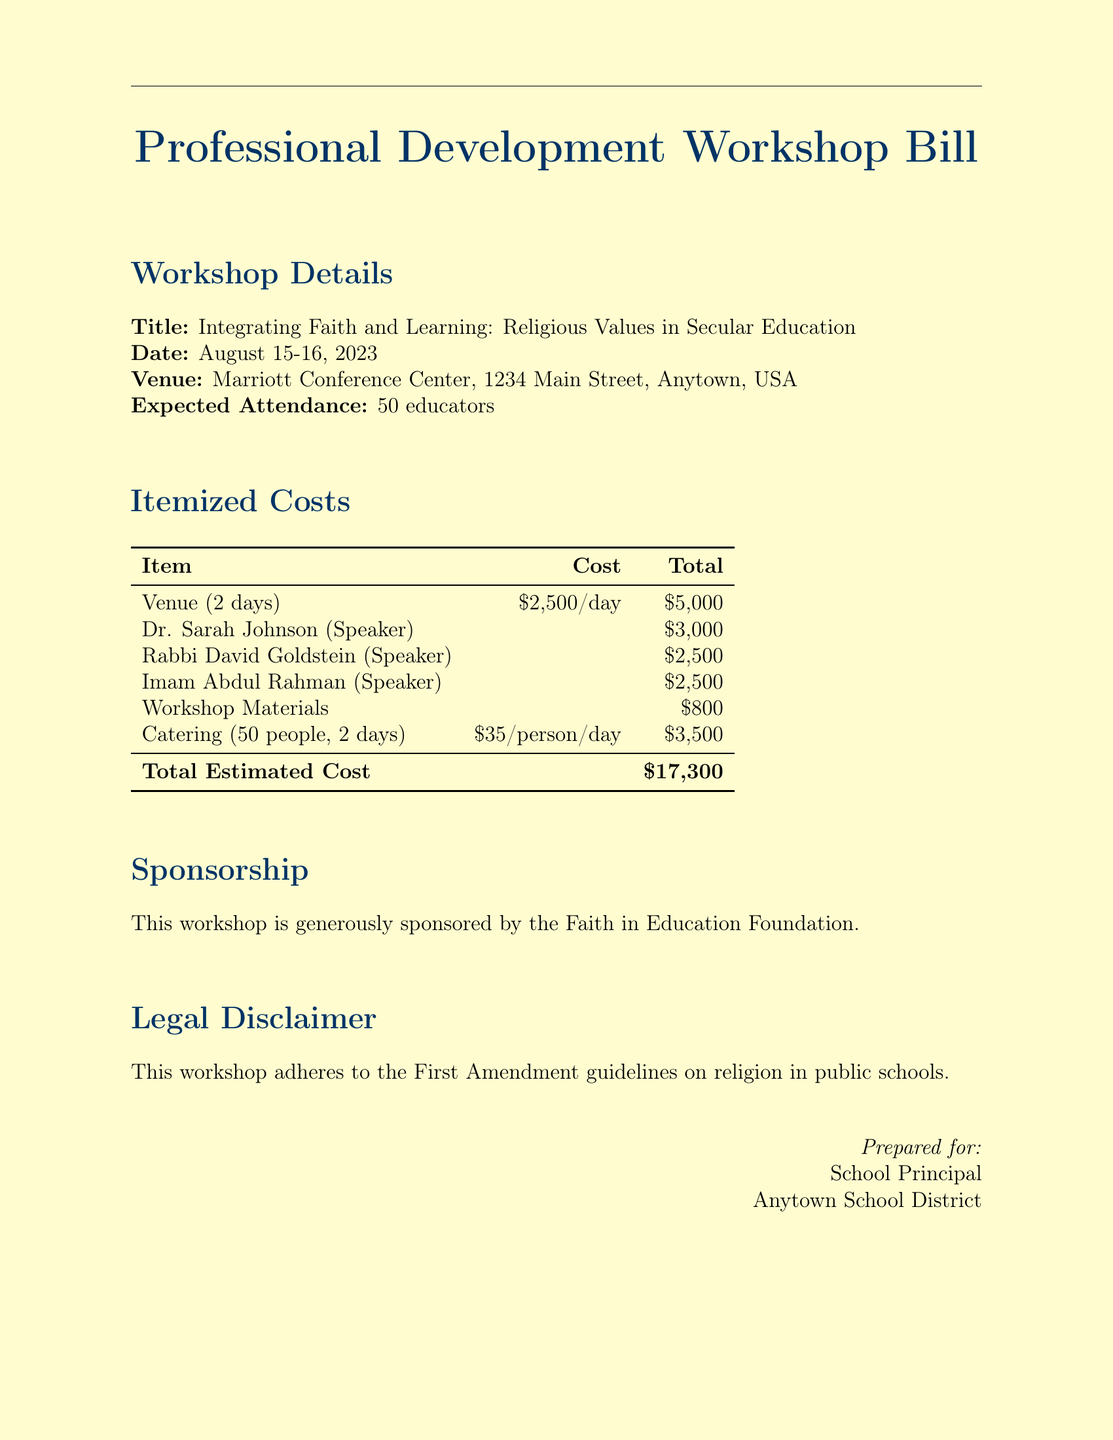What is the title of the workshop? The title of the workshop is explicitly mentioned in the document, providing clarity on the subject matter being discussed.
Answer: Integrating Faith and Learning: Religious Values in Secular Education What is the venue of the workshop? The venue is clearly specified in the document, allowing attendees to know where the workshop will take place.
Answer: Marriott Conference Center, 1234 Main Street, Anytown, USA How much does catering cost for 50 people over 2 days? The catering cost is itemized in the document, and the total can be determined from the per person cost.
Answer: $3,500 Who is the speaker with the highest fee? The speaker fees are listed, and comparing them leads to identifying the one with the highest charge.
Answer: Dr. Sarah Johnson What is the total estimated cost of the workshop? The total estimated cost is explicitly stated in the document, summarizing all individual costs incurred.
Answer: $17,300 What are the dates of the workshop? The dates are provided clearly, indicating when the event will occur.
Answer: August 15-16, 2023 What organization sponsors the workshop? The sponsoring organization is mentioned in the document, giving recognition to the entities involved.
Answer: Faith in Education Foundation Does the workshop adhere to any legal guidelines? The document mentions a legal disclaimer, emphasizing the adherence to relevant regulations.
Answer: First Amendment guidelines on religion in public schools 